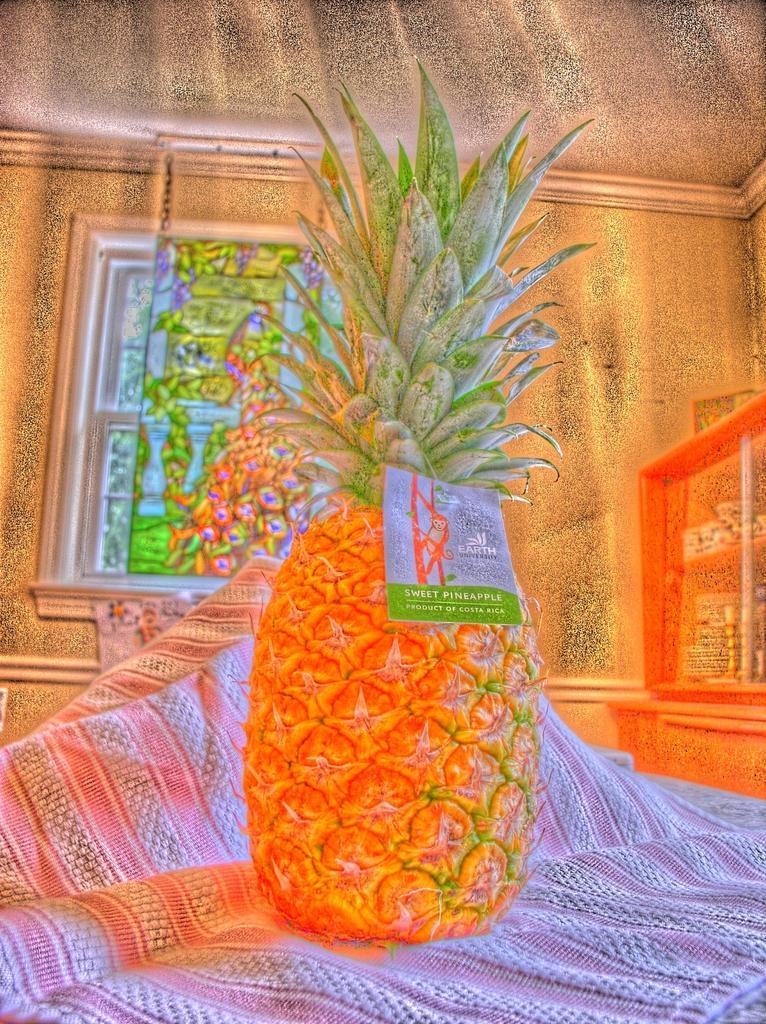How would you summarize this image in a sentence or two? This is an animated image, we can see a pineapple on a cloth. We can see the wall and a window. 